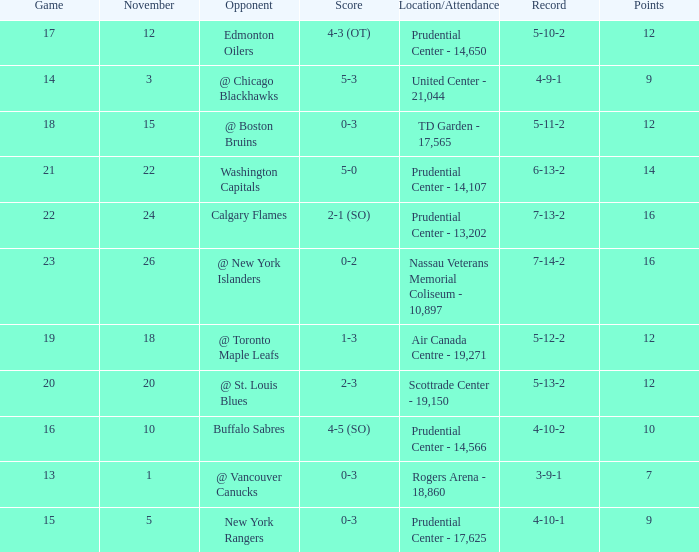What is the total number of locations that had a score of 1-3? 1.0. Parse the table in full. {'header': ['Game', 'November', 'Opponent', 'Score', 'Location/Attendance', 'Record', 'Points'], 'rows': [['17', '12', 'Edmonton Oilers', '4-3 (OT)', 'Prudential Center - 14,650', '5-10-2', '12'], ['14', '3', '@ Chicago Blackhawks', '5-3', 'United Center - 21,044', '4-9-1', '9'], ['18', '15', '@ Boston Bruins', '0-3', 'TD Garden - 17,565', '5-11-2', '12'], ['21', '22', 'Washington Capitals', '5-0', 'Prudential Center - 14,107', '6-13-2', '14'], ['22', '24', 'Calgary Flames', '2-1 (SO)', 'Prudential Center - 13,202', '7-13-2', '16'], ['23', '26', '@ New York Islanders', '0-2', 'Nassau Veterans Memorial Coliseum - 10,897', '7-14-2', '16'], ['19', '18', '@ Toronto Maple Leafs', '1-3', 'Air Canada Centre - 19,271', '5-12-2', '12'], ['20', '20', '@ St. Louis Blues', '2-3', 'Scottrade Center - 19,150', '5-13-2', '12'], ['16', '10', 'Buffalo Sabres', '4-5 (SO)', 'Prudential Center - 14,566', '4-10-2', '10'], ['13', '1', '@ Vancouver Canucks', '0-3', 'Rogers Arena - 18,860', '3-9-1', '7'], ['15', '5', 'New York Rangers', '0-3', 'Prudential Center - 17,625', '4-10-1', '9']]} 